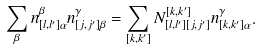Convert formula to latex. <formula><loc_0><loc_0><loc_500><loc_500>\sum _ { \beta } n _ { [ l , l ^ { \prime } ] \alpha } ^ { \beta } n _ { [ j , j ^ { \prime } ] \beta } ^ { \gamma } = \sum _ { [ k , k ^ { \prime } ] } N _ { [ l , l ^ { \prime } ] [ j , j ^ { \prime } ] } ^ { [ k , k ^ { \prime } ] } n _ { [ k , k ^ { \prime } ] \alpha } ^ { \gamma } .</formula> 